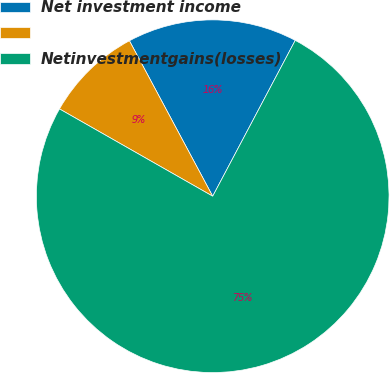Convert chart. <chart><loc_0><loc_0><loc_500><loc_500><pie_chart><fcel>Net investment income<fcel>Unnamed: 1<fcel>Netinvestmentgains(losses)<nl><fcel>15.58%<fcel>8.93%<fcel>75.49%<nl></chart> 